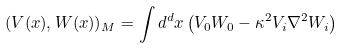<formula> <loc_0><loc_0><loc_500><loc_500>( V ( x ) , W ( x ) ) _ { M } = \int d ^ { d } x \left ( V _ { 0 } W _ { 0 } - \kappa ^ { 2 } V _ { i } \nabla ^ { 2 } W _ { i } \right )</formula> 